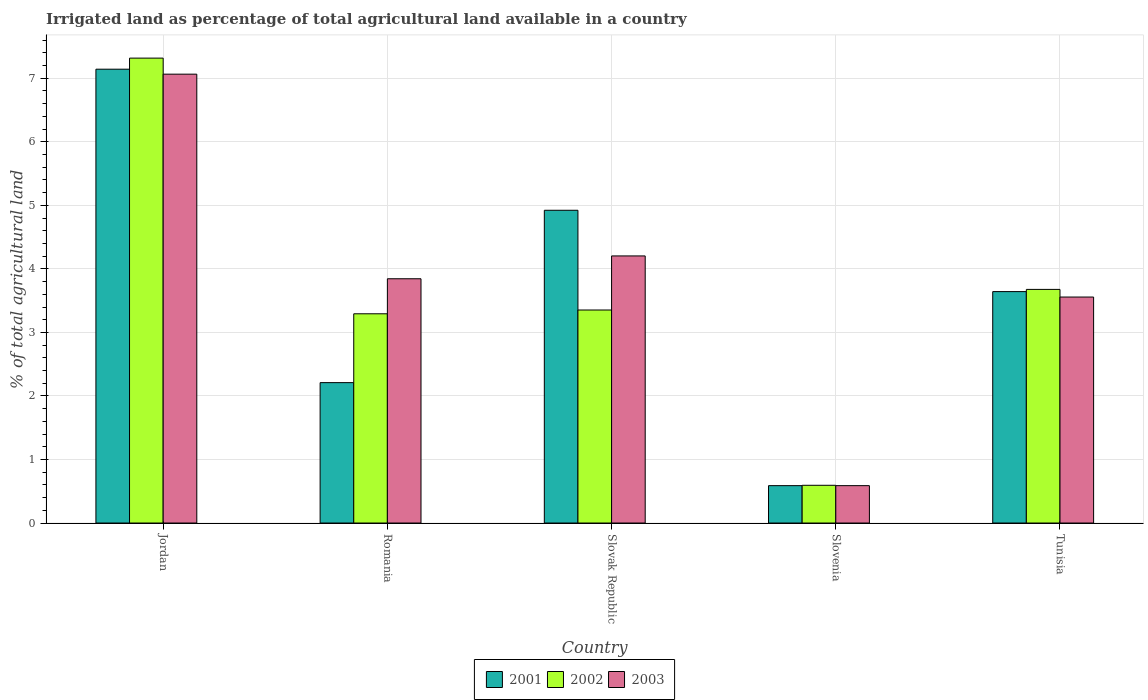How many different coloured bars are there?
Give a very brief answer. 3. How many groups of bars are there?
Provide a succinct answer. 5. How many bars are there on the 4th tick from the right?
Your response must be concise. 3. What is the label of the 2nd group of bars from the left?
Ensure brevity in your answer.  Romania. In how many cases, is the number of bars for a given country not equal to the number of legend labels?
Keep it short and to the point. 0. What is the percentage of irrigated land in 2003 in Slovenia?
Keep it short and to the point. 0.59. Across all countries, what is the maximum percentage of irrigated land in 2003?
Provide a succinct answer. 7.06. Across all countries, what is the minimum percentage of irrigated land in 2003?
Offer a terse response. 0.59. In which country was the percentage of irrigated land in 2002 maximum?
Keep it short and to the point. Jordan. In which country was the percentage of irrigated land in 2003 minimum?
Your response must be concise. Slovenia. What is the total percentage of irrigated land in 2003 in the graph?
Keep it short and to the point. 19.26. What is the difference between the percentage of irrigated land in 2002 in Romania and that in Tunisia?
Offer a very short reply. -0.38. What is the difference between the percentage of irrigated land in 2003 in Jordan and the percentage of irrigated land in 2001 in Slovak Republic?
Make the answer very short. 2.14. What is the average percentage of irrigated land in 2001 per country?
Provide a short and direct response. 3.7. What is the difference between the percentage of irrigated land of/in 2003 and percentage of irrigated land of/in 2001 in Slovak Republic?
Ensure brevity in your answer.  -0.72. In how many countries, is the percentage of irrigated land in 2001 greater than 1 %?
Make the answer very short. 4. What is the ratio of the percentage of irrigated land in 2002 in Slovak Republic to that in Slovenia?
Keep it short and to the point. 5.64. Is the difference between the percentage of irrigated land in 2003 in Romania and Slovenia greater than the difference between the percentage of irrigated land in 2001 in Romania and Slovenia?
Offer a very short reply. Yes. What is the difference between the highest and the second highest percentage of irrigated land in 2003?
Offer a very short reply. -0.36. What is the difference between the highest and the lowest percentage of irrigated land in 2002?
Provide a short and direct response. 6.72. Is the sum of the percentage of irrigated land in 2002 in Romania and Slovak Republic greater than the maximum percentage of irrigated land in 2001 across all countries?
Provide a short and direct response. No. What does the 3rd bar from the right in Slovenia represents?
Keep it short and to the point. 2001. Are all the bars in the graph horizontal?
Keep it short and to the point. No. What is the difference between two consecutive major ticks on the Y-axis?
Ensure brevity in your answer.  1. Are the values on the major ticks of Y-axis written in scientific E-notation?
Offer a very short reply. No. Does the graph contain any zero values?
Give a very brief answer. No. Does the graph contain grids?
Provide a short and direct response. Yes. Where does the legend appear in the graph?
Provide a succinct answer. Bottom center. How are the legend labels stacked?
Keep it short and to the point. Horizontal. What is the title of the graph?
Provide a short and direct response. Irrigated land as percentage of total agricultural land available in a country. What is the label or title of the Y-axis?
Make the answer very short. % of total agricultural land. What is the % of total agricultural land of 2001 in Jordan?
Make the answer very short. 7.14. What is the % of total agricultural land in 2002 in Jordan?
Keep it short and to the point. 7.32. What is the % of total agricultural land in 2003 in Jordan?
Your answer should be very brief. 7.06. What is the % of total agricultural land of 2001 in Romania?
Your answer should be compact. 2.21. What is the % of total agricultural land in 2002 in Romania?
Make the answer very short. 3.29. What is the % of total agricultural land of 2003 in Romania?
Give a very brief answer. 3.84. What is the % of total agricultural land in 2001 in Slovak Republic?
Offer a terse response. 4.92. What is the % of total agricultural land of 2002 in Slovak Republic?
Your answer should be compact. 3.35. What is the % of total agricultural land of 2003 in Slovak Republic?
Your response must be concise. 4.2. What is the % of total agricultural land of 2001 in Slovenia?
Keep it short and to the point. 0.59. What is the % of total agricultural land in 2002 in Slovenia?
Ensure brevity in your answer.  0.59. What is the % of total agricultural land of 2003 in Slovenia?
Offer a very short reply. 0.59. What is the % of total agricultural land in 2001 in Tunisia?
Your answer should be compact. 3.64. What is the % of total agricultural land of 2002 in Tunisia?
Offer a terse response. 3.68. What is the % of total agricultural land in 2003 in Tunisia?
Keep it short and to the point. 3.56. Across all countries, what is the maximum % of total agricultural land of 2001?
Ensure brevity in your answer.  7.14. Across all countries, what is the maximum % of total agricultural land in 2002?
Offer a very short reply. 7.32. Across all countries, what is the maximum % of total agricultural land of 2003?
Your response must be concise. 7.06. Across all countries, what is the minimum % of total agricultural land of 2001?
Provide a succinct answer. 0.59. Across all countries, what is the minimum % of total agricultural land in 2002?
Keep it short and to the point. 0.59. Across all countries, what is the minimum % of total agricultural land in 2003?
Offer a terse response. 0.59. What is the total % of total agricultural land of 2001 in the graph?
Provide a short and direct response. 18.51. What is the total % of total agricultural land in 2002 in the graph?
Your answer should be very brief. 18.23. What is the total % of total agricultural land in 2003 in the graph?
Your response must be concise. 19.26. What is the difference between the % of total agricultural land of 2001 in Jordan and that in Romania?
Offer a very short reply. 4.93. What is the difference between the % of total agricultural land of 2002 in Jordan and that in Romania?
Provide a succinct answer. 4.02. What is the difference between the % of total agricultural land in 2003 in Jordan and that in Romania?
Your response must be concise. 3.22. What is the difference between the % of total agricultural land in 2001 in Jordan and that in Slovak Republic?
Your answer should be very brief. 2.22. What is the difference between the % of total agricultural land in 2002 in Jordan and that in Slovak Republic?
Your answer should be compact. 3.96. What is the difference between the % of total agricultural land in 2003 in Jordan and that in Slovak Republic?
Your response must be concise. 2.86. What is the difference between the % of total agricultural land in 2001 in Jordan and that in Slovenia?
Your answer should be very brief. 6.55. What is the difference between the % of total agricultural land of 2002 in Jordan and that in Slovenia?
Provide a succinct answer. 6.72. What is the difference between the % of total agricultural land of 2003 in Jordan and that in Slovenia?
Ensure brevity in your answer.  6.48. What is the difference between the % of total agricultural land of 2001 in Jordan and that in Tunisia?
Your answer should be very brief. 3.5. What is the difference between the % of total agricultural land of 2002 in Jordan and that in Tunisia?
Your answer should be very brief. 3.64. What is the difference between the % of total agricultural land in 2003 in Jordan and that in Tunisia?
Give a very brief answer. 3.51. What is the difference between the % of total agricultural land of 2001 in Romania and that in Slovak Republic?
Your answer should be very brief. -2.71. What is the difference between the % of total agricultural land of 2002 in Romania and that in Slovak Republic?
Provide a short and direct response. -0.06. What is the difference between the % of total agricultural land in 2003 in Romania and that in Slovak Republic?
Provide a succinct answer. -0.36. What is the difference between the % of total agricultural land of 2001 in Romania and that in Slovenia?
Give a very brief answer. 1.62. What is the difference between the % of total agricultural land of 2002 in Romania and that in Slovenia?
Your response must be concise. 2.7. What is the difference between the % of total agricultural land in 2003 in Romania and that in Slovenia?
Ensure brevity in your answer.  3.26. What is the difference between the % of total agricultural land of 2001 in Romania and that in Tunisia?
Ensure brevity in your answer.  -1.43. What is the difference between the % of total agricultural land in 2002 in Romania and that in Tunisia?
Your answer should be compact. -0.38. What is the difference between the % of total agricultural land of 2003 in Romania and that in Tunisia?
Offer a terse response. 0.29. What is the difference between the % of total agricultural land in 2001 in Slovak Republic and that in Slovenia?
Provide a short and direct response. 4.33. What is the difference between the % of total agricultural land in 2002 in Slovak Republic and that in Slovenia?
Your answer should be very brief. 2.76. What is the difference between the % of total agricultural land in 2003 in Slovak Republic and that in Slovenia?
Your response must be concise. 3.62. What is the difference between the % of total agricultural land in 2001 in Slovak Republic and that in Tunisia?
Make the answer very short. 1.28. What is the difference between the % of total agricultural land in 2002 in Slovak Republic and that in Tunisia?
Your response must be concise. -0.32. What is the difference between the % of total agricultural land in 2003 in Slovak Republic and that in Tunisia?
Your response must be concise. 0.65. What is the difference between the % of total agricultural land of 2001 in Slovenia and that in Tunisia?
Keep it short and to the point. -3.05. What is the difference between the % of total agricultural land of 2002 in Slovenia and that in Tunisia?
Keep it short and to the point. -3.08. What is the difference between the % of total agricultural land of 2003 in Slovenia and that in Tunisia?
Your answer should be very brief. -2.97. What is the difference between the % of total agricultural land of 2001 in Jordan and the % of total agricultural land of 2002 in Romania?
Offer a terse response. 3.85. What is the difference between the % of total agricultural land of 2001 in Jordan and the % of total agricultural land of 2003 in Romania?
Provide a succinct answer. 3.3. What is the difference between the % of total agricultural land in 2002 in Jordan and the % of total agricultural land in 2003 in Romania?
Keep it short and to the point. 3.47. What is the difference between the % of total agricultural land in 2001 in Jordan and the % of total agricultural land in 2002 in Slovak Republic?
Your response must be concise. 3.79. What is the difference between the % of total agricultural land in 2001 in Jordan and the % of total agricultural land in 2003 in Slovak Republic?
Make the answer very short. 2.94. What is the difference between the % of total agricultural land of 2002 in Jordan and the % of total agricultural land of 2003 in Slovak Republic?
Your answer should be compact. 3.11. What is the difference between the % of total agricultural land in 2001 in Jordan and the % of total agricultural land in 2002 in Slovenia?
Your response must be concise. 6.55. What is the difference between the % of total agricultural land in 2001 in Jordan and the % of total agricultural land in 2003 in Slovenia?
Ensure brevity in your answer.  6.55. What is the difference between the % of total agricultural land of 2002 in Jordan and the % of total agricultural land of 2003 in Slovenia?
Your response must be concise. 6.73. What is the difference between the % of total agricultural land in 2001 in Jordan and the % of total agricultural land in 2002 in Tunisia?
Ensure brevity in your answer.  3.47. What is the difference between the % of total agricultural land of 2001 in Jordan and the % of total agricultural land of 2003 in Tunisia?
Provide a short and direct response. 3.59. What is the difference between the % of total agricultural land of 2002 in Jordan and the % of total agricultural land of 2003 in Tunisia?
Make the answer very short. 3.76. What is the difference between the % of total agricultural land of 2001 in Romania and the % of total agricultural land of 2002 in Slovak Republic?
Offer a terse response. -1.14. What is the difference between the % of total agricultural land of 2001 in Romania and the % of total agricultural land of 2003 in Slovak Republic?
Offer a very short reply. -1.99. What is the difference between the % of total agricultural land in 2002 in Romania and the % of total agricultural land in 2003 in Slovak Republic?
Provide a short and direct response. -0.91. What is the difference between the % of total agricultural land of 2001 in Romania and the % of total agricultural land of 2002 in Slovenia?
Provide a succinct answer. 1.62. What is the difference between the % of total agricultural land of 2001 in Romania and the % of total agricultural land of 2003 in Slovenia?
Your answer should be very brief. 1.62. What is the difference between the % of total agricultural land of 2002 in Romania and the % of total agricultural land of 2003 in Slovenia?
Offer a very short reply. 2.71. What is the difference between the % of total agricultural land in 2001 in Romania and the % of total agricultural land in 2002 in Tunisia?
Keep it short and to the point. -1.47. What is the difference between the % of total agricultural land of 2001 in Romania and the % of total agricultural land of 2003 in Tunisia?
Offer a terse response. -1.35. What is the difference between the % of total agricultural land in 2002 in Romania and the % of total agricultural land in 2003 in Tunisia?
Provide a short and direct response. -0.26. What is the difference between the % of total agricultural land in 2001 in Slovak Republic and the % of total agricultural land in 2002 in Slovenia?
Provide a short and direct response. 4.33. What is the difference between the % of total agricultural land of 2001 in Slovak Republic and the % of total agricultural land of 2003 in Slovenia?
Provide a short and direct response. 4.33. What is the difference between the % of total agricultural land in 2002 in Slovak Republic and the % of total agricultural land in 2003 in Slovenia?
Your answer should be very brief. 2.76. What is the difference between the % of total agricultural land in 2001 in Slovak Republic and the % of total agricultural land in 2002 in Tunisia?
Your answer should be very brief. 1.25. What is the difference between the % of total agricultural land in 2001 in Slovak Republic and the % of total agricultural land in 2003 in Tunisia?
Provide a short and direct response. 1.37. What is the difference between the % of total agricultural land of 2002 in Slovak Republic and the % of total agricultural land of 2003 in Tunisia?
Your response must be concise. -0.2. What is the difference between the % of total agricultural land of 2001 in Slovenia and the % of total agricultural land of 2002 in Tunisia?
Provide a succinct answer. -3.09. What is the difference between the % of total agricultural land in 2001 in Slovenia and the % of total agricultural land in 2003 in Tunisia?
Make the answer very short. -2.97. What is the difference between the % of total agricultural land of 2002 in Slovenia and the % of total agricultural land of 2003 in Tunisia?
Make the answer very short. -2.96. What is the average % of total agricultural land of 2001 per country?
Ensure brevity in your answer.  3.7. What is the average % of total agricultural land of 2002 per country?
Make the answer very short. 3.65. What is the average % of total agricultural land in 2003 per country?
Provide a short and direct response. 3.85. What is the difference between the % of total agricultural land in 2001 and % of total agricultural land in 2002 in Jordan?
Give a very brief answer. -0.17. What is the difference between the % of total agricultural land of 2001 and % of total agricultural land of 2003 in Jordan?
Offer a very short reply. 0.08. What is the difference between the % of total agricultural land of 2002 and % of total agricultural land of 2003 in Jordan?
Provide a short and direct response. 0.25. What is the difference between the % of total agricultural land of 2001 and % of total agricultural land of 2002 in Romania?
Your answer should be very brief. -1.08. What is the difference between the % of total agricultural land of 2001 and % of total agricultural land of 2003 in Romania?
Provide a succinct answer. -1.63. What is the difference between the % of total agricultural land of 2002 and % of total agricultural land of 2003 in Romania?
Your answer should be very brief. -0.55. What is the difference between the % of total agricultural land in 2001 and % of total agricultural land in 2002 in Slovak Republic?
Your answer should be very brief. 1.57. What is the difference between the % of total agricultural land of 2001 and % of total agricultural land of 2003 in Slovak Republic?
Offer a terse response. 0.72. What is the difference between the % of total agricultural land in 2002 and % of total agricultural land in 2003 in Slovak Republic?
Offer a very short reply. -0.85. What is the difference between the % of total agricultural land of 2001 and % of total agricultural land of 2002 in Slovenia?
Your answer should be compact. -0.01. What is the difference between the % of total agricultural land in 2002 and % of total agricultural land in 2003 in Slovenia?
Your answer should be very brief. 0.01. What is the difference between the % of total agricultural land of 2001 and % of total agricultural land of 2002 in Tunisia?
Your answer should be compact. -0.03. What is the difference between the % of total agricultural land in 2001 and % of total agricultural land in 2003 in Tunisia?
Keep it short and to the point. 0.09. What is the difference between the % of total agricultural land of 2002 and % of total agricultural land of 2003 in Tunisia?
Your answer should be compact. 0.12. What is the ratio of the % of total agricultural land in 2001 in Jordan to that in Romania?
Offer a terse response. 3.23. What is the ratio of the % of total agricultural land of 2002 in Jordan to that in Romania?
Provide a succinct answer. 2.22. What is the ratio of the % of total agricultural land in 2003 in Jordan to that in Romania?
Your response must be concise. 1.84. What is the ratio of the % of total agricultural land of 2001 in Jordan to that in Slovak Republic?
Provide a succinct answer. 1.45. What is the ratio of the % of total agricultural land in 2002 in Jordan to that in Slovak Republic?
Offer a very short reply. 2.18. What is the ratio of the % of total agricultural land in 2003 in Jordan to that in Slovak Republic?
Provide a short and direct response. 1.68. What is the ratio of the % of total agricultural land of 2001 in Jordan to that in Slovenia?
Give a very brief answer. 12.14. What is the ratio of the % of total agricultural land in 2002 in Jordan to that in Slovenia?
Your answer should be compact. 12.32. What is the ratio of the % of total agricultural land of 2003 in Jordan to that in Slovenia?
Provide a succinct answer. 12.01. What is the ratio of the % of total agricultural land of 2001 in Jordan to that in Tunisia?
Make the answer very short. 1.96. What is the ratio of the % of total agricultural land of 2002 in Jordan to that in Tunisia?
Make the answer very short. 1.99. What is the ratio of the % of total agricultural land in 2003 in Jordan to that in Tunisia?
Provide a short and direct response. 1.99. What is the ratio of the % of total agricultural land in 2001 in Romania to that in Slovak Republic?
Offer a terse response. 0.45. What is the ratio of the % of total agricultural land of 2002 in Romania to that in Slovak Republic?
Provide a succinct answer. 0.98. What is the ratio of the % of total agricultural land of 2003 in Romania to that in Slovak Republic?
Your answer should be compact. 0.91. What is the ratio of the % of total agricultural land of 2001 in Romania to that in Slovenia?
Provide a succinct answer. 3.76. What is the ratio of the % of total agricultural land of 2002 in Romania to that in Slovenia?
Offer a terse response. 5.54. What is the ratio of the % of total agricultural land in 2003 in Romania to that in Slovenia?
Offer a terse response. 6.54. What is the ratio of the % of total agricultural land in 2001 in Romania to that in Tunisia?
Your answer should be compact. 0.61. What is the ratio of the % of total agricultural land in 2002 in Romania to that in Tunisia?
Your response must be concise. 0.9. What is the ratio of the % of total agricultural land of 2003 in Romania to that in Tunisia?
Give a very brief answer. 1.08. What is the ratio of the % of total agricultural land in 2001 in Slovak Republic to that in Slovenia?
Provide a succinct answer. 8.37. What is the ratio of the % of total agricultural land of 2002 in Slovak Republic to that in Slovenia?
Your answer should be compact. 5.64. What is the ratio of the % of total agricultural land of 2003 in Slovak Republic to that in Slovenia?
Your answer should be compact. 7.15. What is the ratio of the % of total agricultural land of 2001 in Slovak Republic to that in Tunisia?
Keep it short and to the point. 1.35. What is the ratio of the % of total agricultural land in 2002 in Slovak Republic to that in Tunisia?
Offer a very short reply. 0.91. What is the ratio of the % of total agricultural land of 2003 in Slovak Republic to that in Tunisia?
Make the answer very short. 1.18. What is the ratio of the % of total agricultural land in 2001 in Slovenia to that in Tunisia?
Your answer should be very brief. 0.16. What is the ratio of the % of total agricultural land of 2002 in Slovenia to that in Tunisia?
Your answer should be very brief. 0.16. What is the ratio of the % of total agricultural land in 2003 in Slovenia to that in Tunisia?
Provide a succinct answer. 0.17. What is the difference between the highest and the second highest % of total agricultural land of 2001?
Offer a terse response. 2.22. What is the difference between the highest and the second highest % of total agricultural land in 2002?
Ensure brevity in your answer.  3.64. What is the difference between the highest and the second highest % of total agricultural land of 2003?
Provide a short and direct response. 2.86. What is the difference between the highest and the lowest % of total agricultural land in 2001?
Your answer should be compact. 6.55. What is the difference between the highest and the lowest % of total agricultural land of 2002?
Provide a succinct answer. 6.72. What is the difference between the highest and the lowest % of total agricultural land in 2003?
Provide a succinct answer. 6.48. 